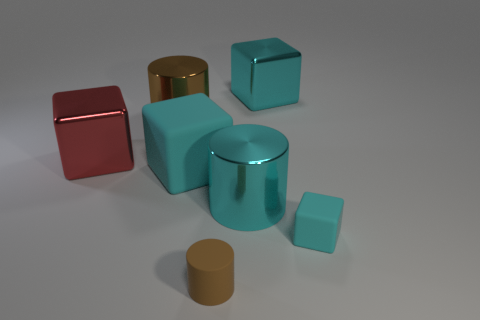What number of objects are tiny rubber things behind the small rubber cylinder or tiny yellow cylinders?
Provide a succinct answer. 1. There is a big cyan object behind the big matte cube in front of the large cyan thing that is right of the large cyan cylinder; what is its shape?
Give a very brief answer. Cube. What number of other matte objects are the same shape as the red object?
Provide a short and direct response. 2. There is a big cylinder that is the same color as the small cube; what is it made of?
Provide a succinct answer. Metal. Do the big red thing and the big cyan cylinder have the same material?
Your response must be concise. Yes. There is a metal cylinder that is to the right of the brown object behind the big red shiny thing; what number of large brown shiny cylinders are in front of it?
Offer a terse response. 0. Is there a yellow object made of the same material as the red thing?
Give a very brief answer. No. What size is the cylinder that is the same color as the big rubber object?
Offer a terse response. Large. Are there fewer cyan rubber objects than small cyan matte things?
Provide a succinct answer. No. Does the matte object that is on the right side of the tiny brown object have the same color as the big matte object?
Give a very brief answer. Yes. 